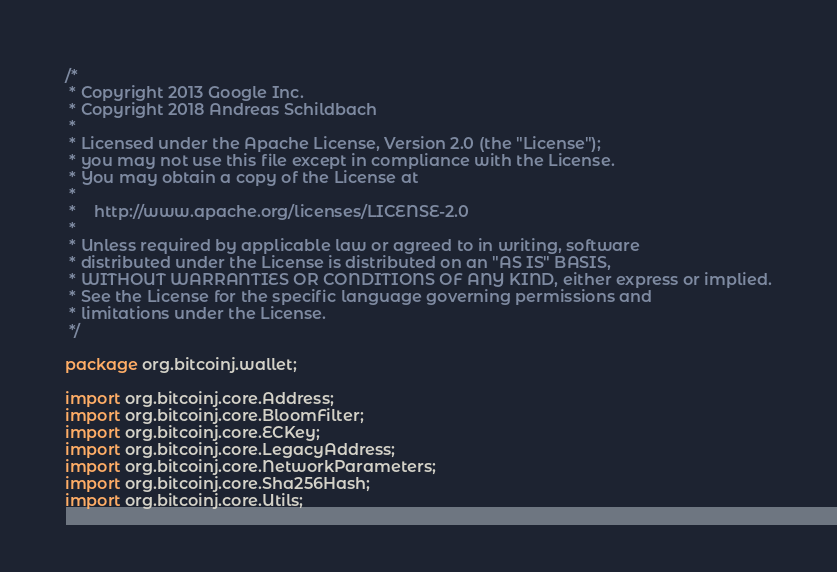Convert code to text. <code><loc_0><loc_0><loc_500><loc_500><_Java_>/*
 * Copyright 2013 Google Inc.
 * Copyright 2018 Andreas Schildbach
 *
 * Licensed under the Apache License, Version 2.0 (the "License");
 * you may not use this file except in compliance with the License.
 * You may obtain a copy of the License at
 *
 *    http://www.apache.org/licenses/LICENSE-2.0
 *
 * Unless required by applicable law or agreed to in writing, software
 * distributed under the License is distributed on an "AS IS" BASIS,
 * WITHOUT WARRANTIES OR CONDITIONS OF ANY KIND, either express or implied.
 * See the License for the specific language governing permissions and
 * limitations under the License.
 */

package org.bitcoinj.wallet;

import org.bitcoinj.core.Address;
import org.bitcoinj.core.BloomFilter;
import org.bitcoinj.core.ECKey;
import org.bitcoinj.core.LegacyAddress;
import org.bitcoinj.core.NetworkParameters;
import org.bitcoinj.core.Sha256Hash;
import org.bitcoinj.core.Utils;</code> 